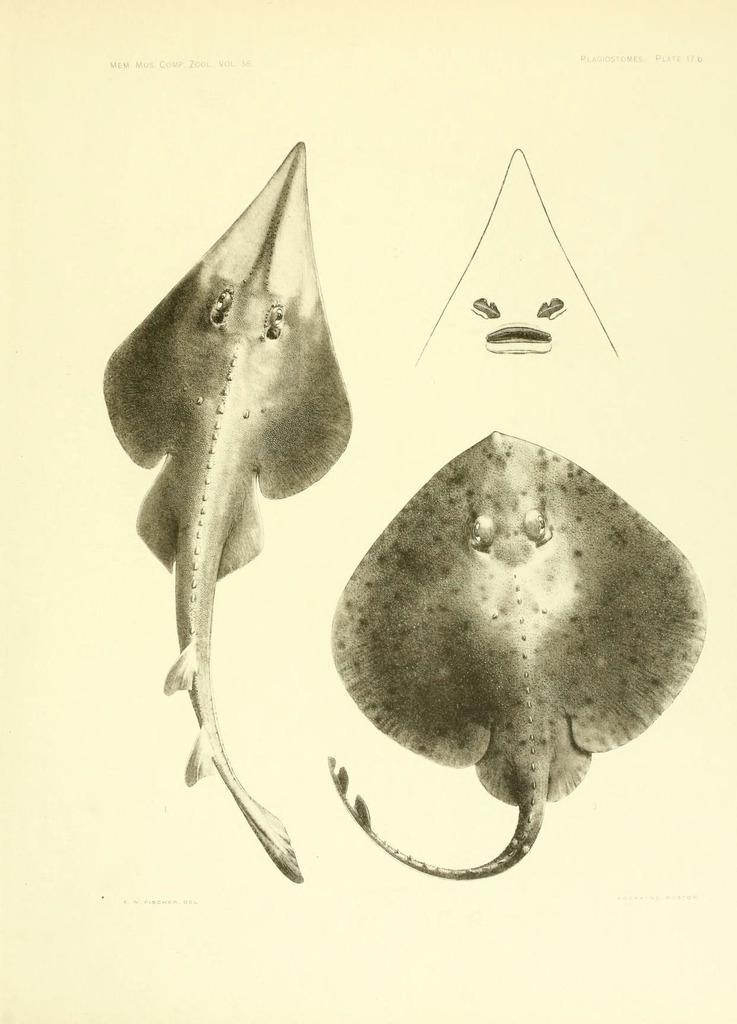Describe this image in one or two sentences. In this picture we can see sketches of water species. 